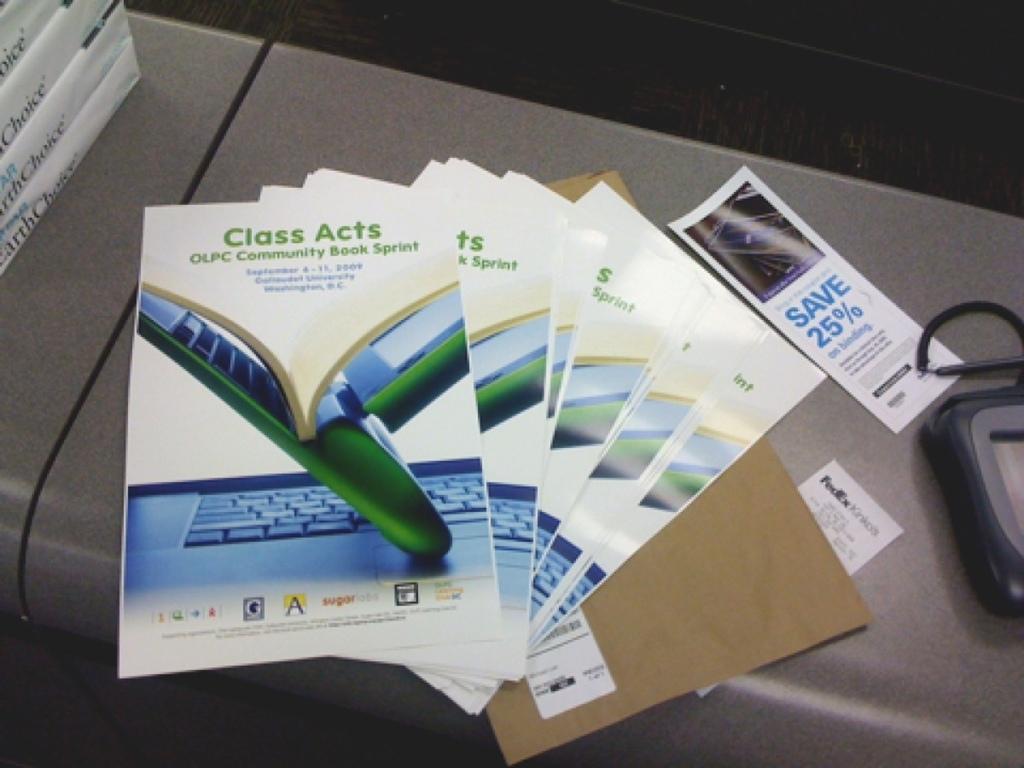What are they advertising?
Offer a terse response. Class acts. How much can you save according to the brochure on the side?
Make the answer very short. 25%. 